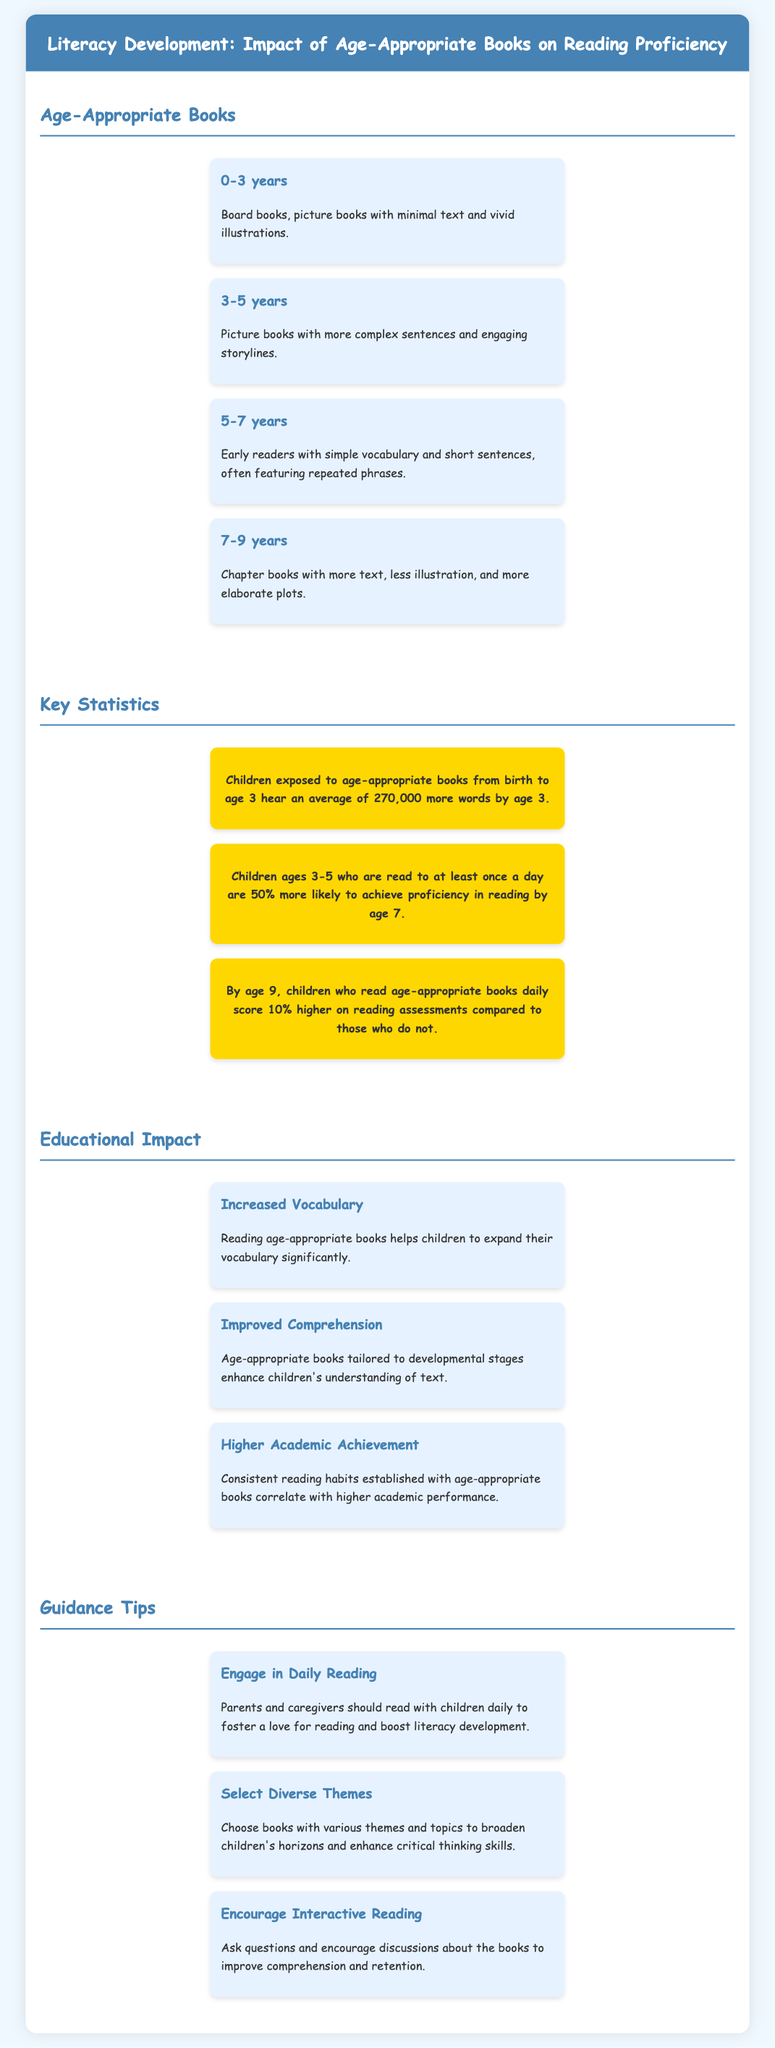what age range is mentioned for board books? The document specifies that board books are recommended for children aged 0-3 years.
Answer: 0-3 years how much more vocabulary do children hear by age 3 when exposed to age-appropriate books? The statistic states that children hear an average of 270,000 more words by age 3 if exposed to age-appropriate books from birth.
Answer: 270,000 what percentage more likely are children aged 3-5 who are read to daily to achieve reading proficiency by age 7? The document claims that children ages 3-5 read to daily are 50% more likely to achieve proficiency by age 7.
Answer: 50% what is one educational impact of reading age-appropriate books? The infographic lists several impacts, one being increased vocabulary as a result of reading.
Answer: Increased Vocabulary what is a tip for fostering literacy development? The document suggests engaging in daily reading with children as a way to boost literacy development.
Answer: Engage in Daily Reading what type of books should be selected for children aged 5-7 years? The document indicates that early readers are suitable for the 5-7 age range.
Answer: Early Readers 